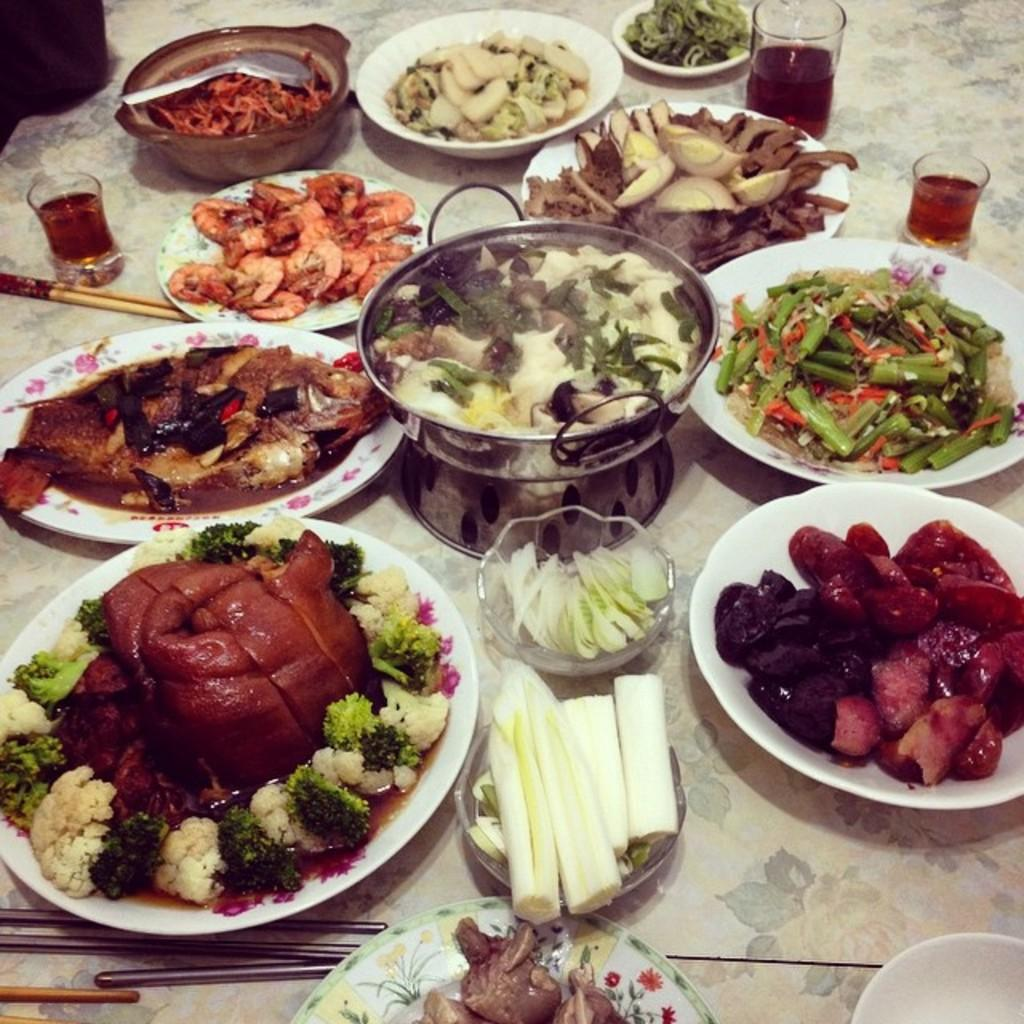What type of tableware can be seen on the table in the image? There are bowls, plates, wine glasses, a spoon, and chopsticks on the table. What type of food is present on the table? There is meat, potato pieces, onion pieces, cabbage pieces, and other food items on the table. How many different types of food items are on the table? There are at least five different types of food items on the table: meat, potato pieces, onion pieces, cabbage pieces, and other food items. What might be used for serving or eating the food on the table? The bowls, plates, and utensils such as the spoon and chopsticks might be used for serving or eating the food on the table. Where is the oven located in the image? There is no oven present in the image. What type of crook is visible in the image? There is no crook present in the image. 